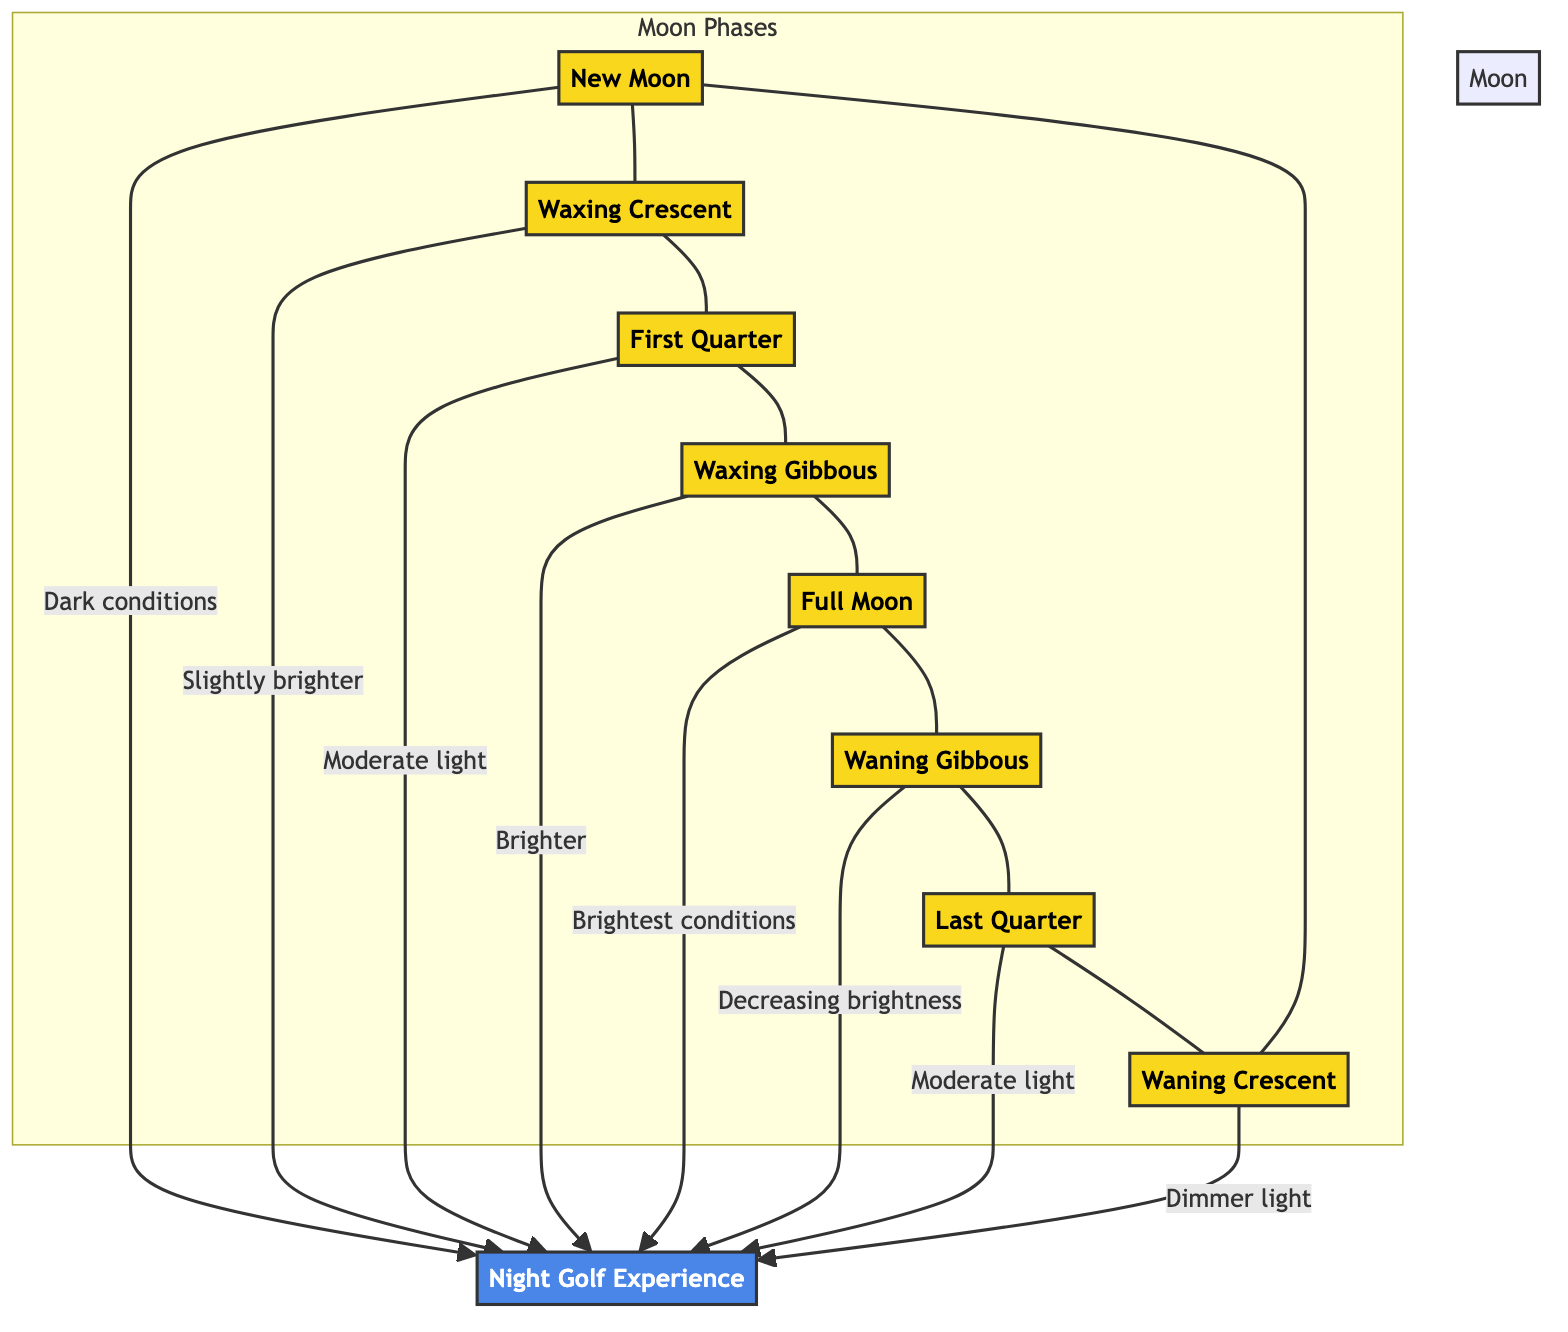What is the first phase of the moon listed in the diagram? The diagram shows phases of the moon starting with "New Moon," which is the first phase mentioned in the sequence of phases.
Answer: New Moon How many different phases of the moon are represented in the diagram? The diagram displays eight distinct phases of the moon, counted directly from the nodes present: New Moon, Waxing Crescent, First Quarter, Waxing Gibbous, Full Moon, Waning Gibbous, Last Quarter, and Waning Crescent.
Answer: 8 Which moon phase has the brightest conditions for night golfing? According to the diagram, the "Full Moon" phase is indicated as providing the "Brightest conditions" for night golfing experiences, making it the best choice for optimal visibility.
Answer: Full Moon What is the light condition associated with the Waxing Gibbous phase? In the diagram, "Waxing Gibbous" is stated to provide "Brighter" conditions for nighttime golfing, which conveys a moderately high level of light available for playing.
Answer: Brighter Which two moon phases provide moderate light? The diagram identifies both "First Quarter" and "Last Quarter" as phases that offer "Moderate light" conditions, indicating they are similar in terms of light availability for golfing.
Answer: First Quarter, Last Quarter During which moon phase does the brightness start to decrease after being bright? The diagram indicates that "Waning Gibbous" phase follows the "Full Moon" and is noted for "Decreasing brightness," suggesting it is the first phase after the peak brightness where the light starts to diminish.
Answer: Waning Gibbous What is the relationship between the Waxing Crescent and the Moon New phase? In the diagram, the "Waxing Crescent" follows directly after the "New Moon," indicating a sequential progression in the lunar cycle where the moon begins to become more illuminated following the complete darkness of the new moon.
Answer: Sequential progression What influence does the New Moon phase have on night golfing events? As detailed in the diagram, the "New Moon" phase is associated with "Dark conditions," implying that this phase provides very limited moonlight for nighttime golfing, which can severely impact visibility and gameplay.
Answer: Dark conditions 